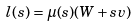Convert formula to latex. <formula><loc_0><loc_0><loc_500><loc_500>l ( s ) = \mu ( s ) ( W + s v )</formula> 